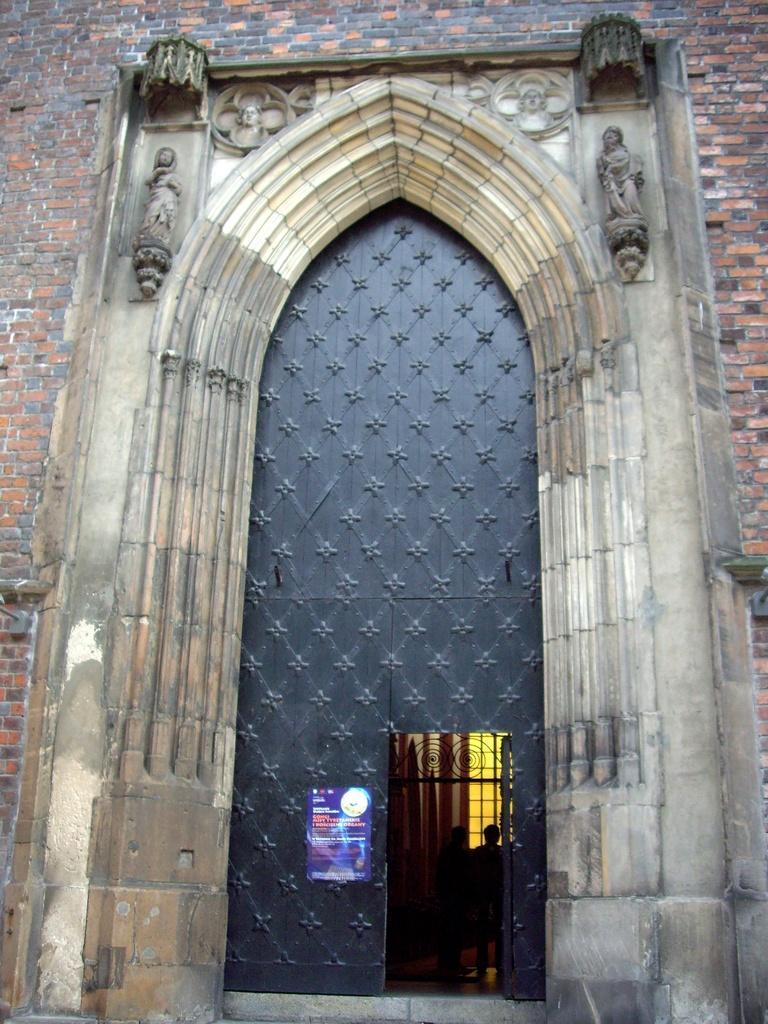Can you describe this image briefly? In this image I can see the building which is made up of bricks and I can see a huge gate which is black in color, a poster attached to it and through the door I can see few persons standing and few other objects. 